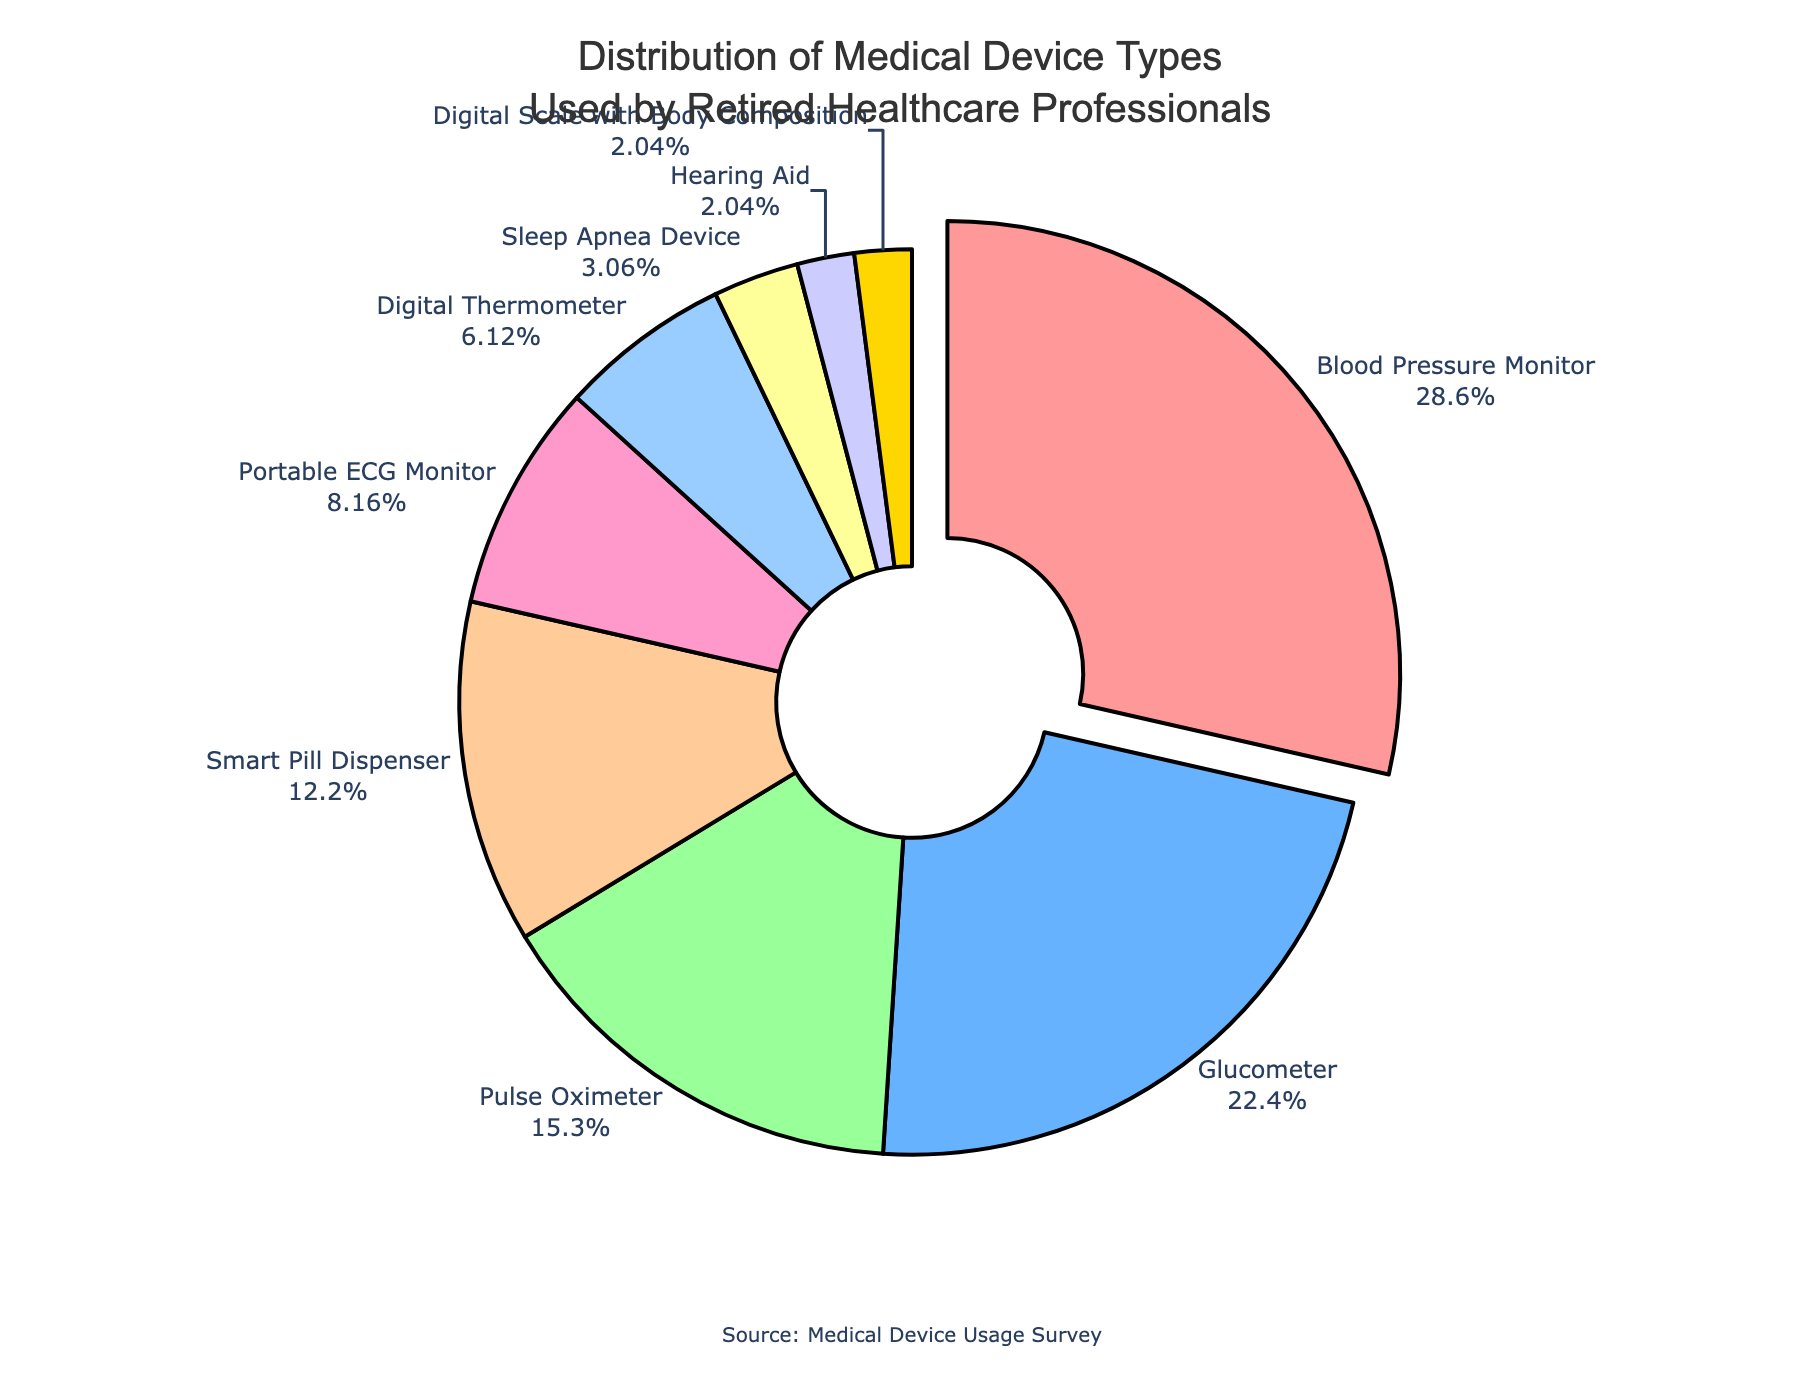What percentage of retired healthcare professionals use Blood Pressure Monitors? The chart shows that the segment for Blood Pressure Monitors is labeled with 28%.
Answer: 28% How much more common is the usage of Blood Pressure Monitors than Glucometers? Blood Pressure Monitors have a usage percentage of 28%, whereas Glucometers have 22%. The difference is 28% - 22% = 6%.
Answer: 6% Which medical device type has the smallest usage percentage? The smallest segment in the pie chart corresponds to Hearing Aids and Digital Scales with Body Composition, both showing 2%.
Answer: Hearing Aid and Digital Scale with Body Composition What is the combined usage percentage of Pulse Oximeters and Smart Pill Dispensers? The usage for Pulse Oximeters is 15% and for Smart Pill Dispensers is 12%. Adding these together results in 15% + 12% = 27%.
Answer: 27% Is the usage of Portable ECG Monitors greater than or less than the usage of Digital Thermometers? Portable ECG Monitors have a usage percentage of 8%, while Digital Thermometers have 6%. Comparing these, 8% is greater than 6%.
Answer: Greater Which device type is highlighted (pulled out) in the pie chart? The chart highlights (pulls out) the segment with the highest percentage, which refers to Blood Pressure Monitors.
Answer: Blood Pressure Monitor What is the total percentage of the four least common device types? The four least common device types are Sleep Apnea Device (3%), Hearing Aid (2%), Digital Scale with Body Composition (2%), and Digital Thermometer (6%). Adding these, 3% + 2% + 2% + 6% = 13%.
Answer: 13% Which color represents the Glucometer segment in the pie chart? The second segment in the pie chart, colored light blue, represents the Glucometer with a 22% usage rate.
Answer: Light blue What is the difference in percentage usage between Smart Pill Dispenser and Portable ECG Monitor? Smart Pill Dispenser has a percentage usage of 12%, and Portable ECG Monitor has 8%. The difference is 12% - 8% = 4%.
Answer: 4% Which three device types have usage percentages above 20%? The pie chart shows Blood Pressure Monitor (28%), Glucometer (22%), and no other devices exceed 20%.
Answer: Blood Pressure Monitor and Glucometer 